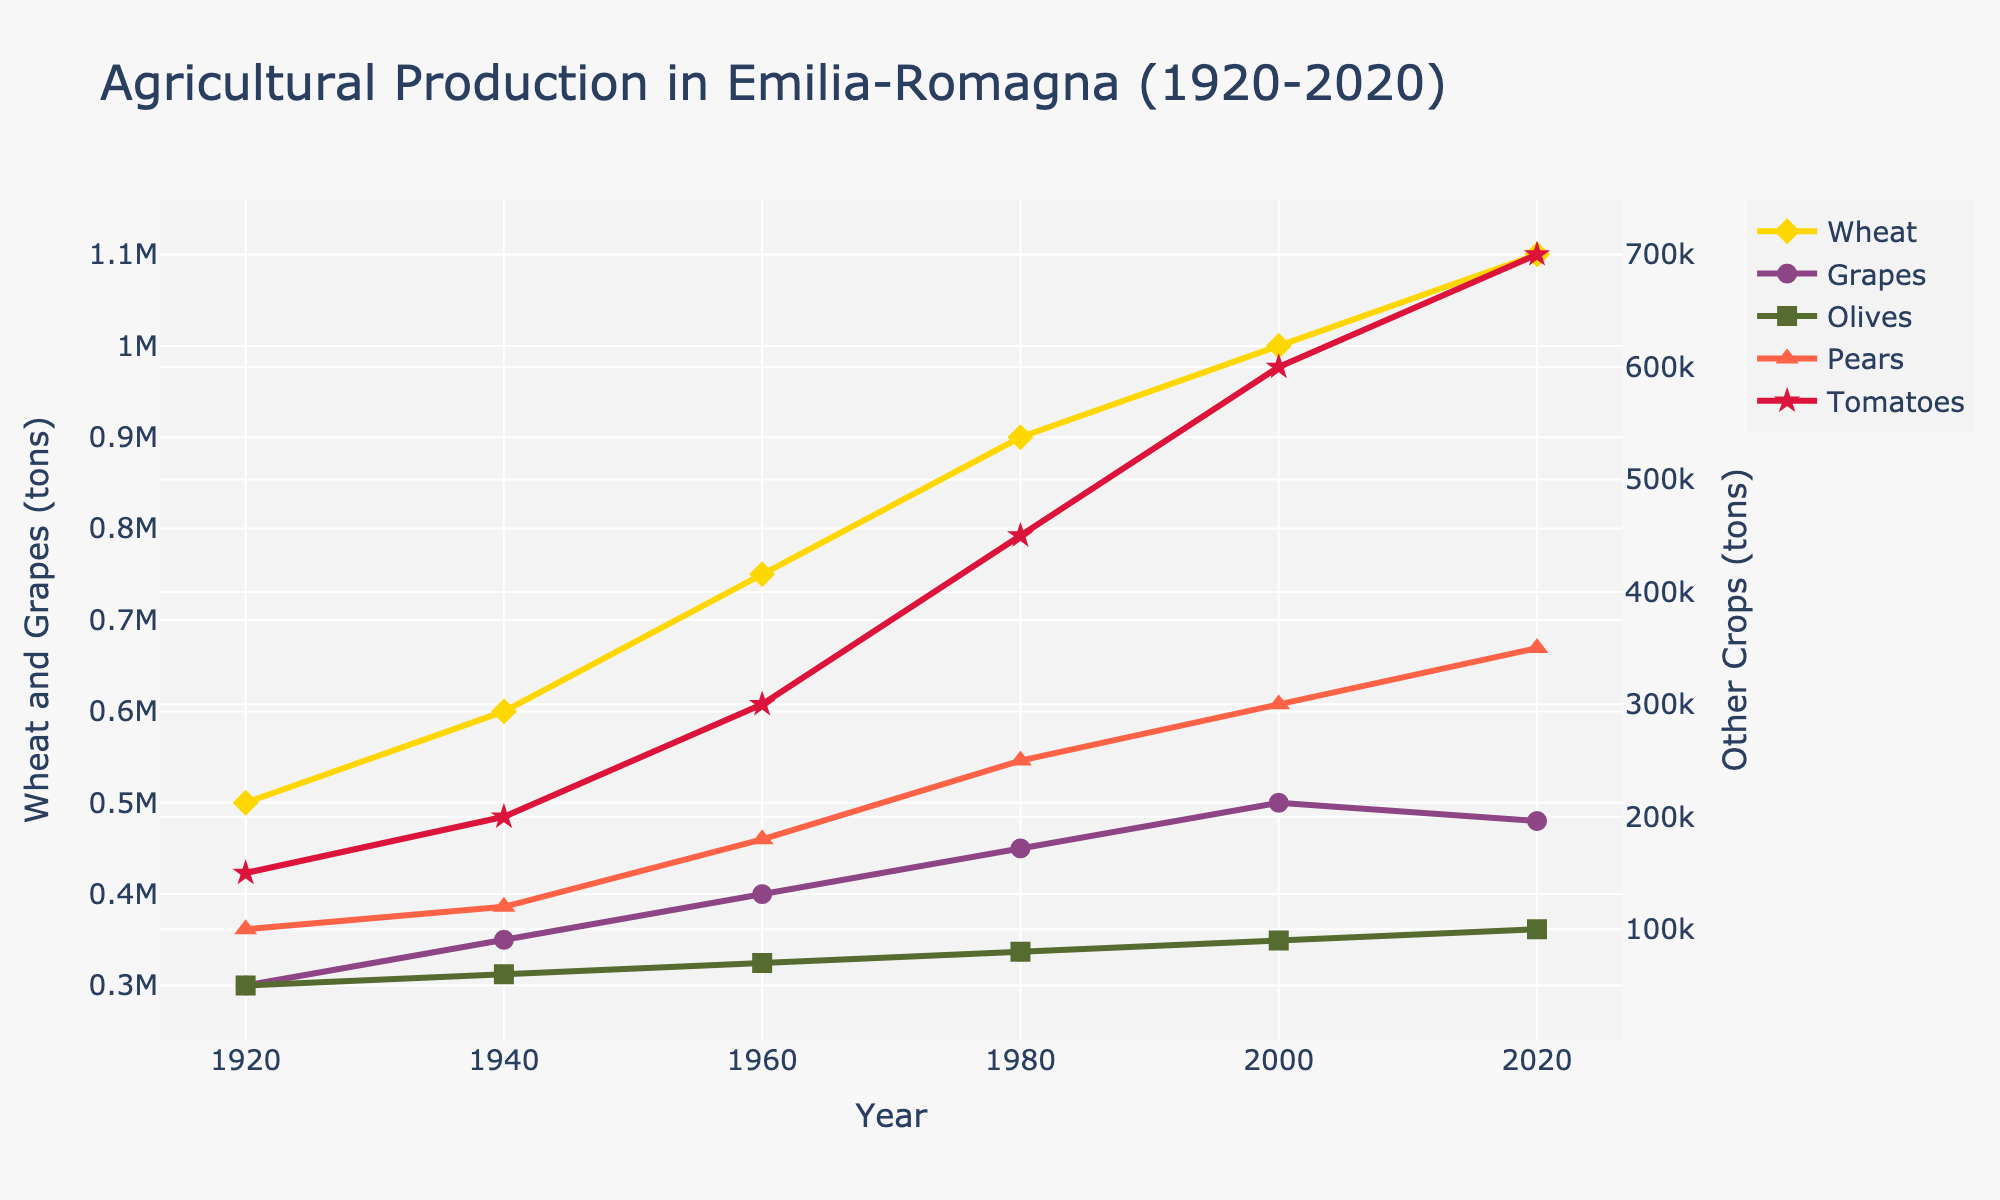In which year did wheat production reach 1,000,000 tons? From the figure, observe the yellow line representing wheat production. Follow it until it intersects with the 1,000,000-ton mark on the vertical axis, which occurs in the year 2000.
Answer: 2000 Which crop showed a decrease in production between 2000 and 2020? Compare the production levels of each crop in 2000 and 2020. Grapes are represented by a purple line, which shows a slight decrease from 500,000 tons in 2000 to 480,000 tons in 2020.
Answer: Grapes What is the combined total of tomato and pear production in 1980? Identify the quantities for tomatoes and pears in 1980 from the figure. Tomatoes (red line) were at 450,000 tons, and pears (tomato-colored triangle line) were at 250,000 tons. Summing these gives 450,000 + 250,000 = 700,000 tons.
Answer: 700,000 tons Which crop had the highest production in 2020? Look at the production values for all crops in 2020. The red line, corresponding to tomatoes, had the highest production at 700,000 tons.
Answer: Tomatoes How did olive production change from 1920 to 1960? Trace the olive production line (green square) from 1920 to 1960. Olive production increased from 50,000 tons in 1920 to 70,000 tons in 1960, an increase of 20,000 tons.
Answer: Increased by 20,000 tons Which crop had the smallest production increase over the century? Observe each crop's production in 1920 and 2020, then calculate the difference. Wheat increased from 500,000 to 1,100,000 tons, grapes from 300,000 to 480,000 tons, olives from 50,000 to 100,000 tons, pears from 100,000 to 350,000 tons, and tomatoes from 150,000 to 700,000 tons. Olives had the smallest increase of 50,000 tons.
Answer: Olives How many tons of grapes were produced in 1940 compared to 2020? Refer to the grape production values (purple line) for both years. In 1940, grape production was 350,000 tons, and in 2020, it was 480,000 tons.
Answer: 350,000 tons vs. 480,000 tons 